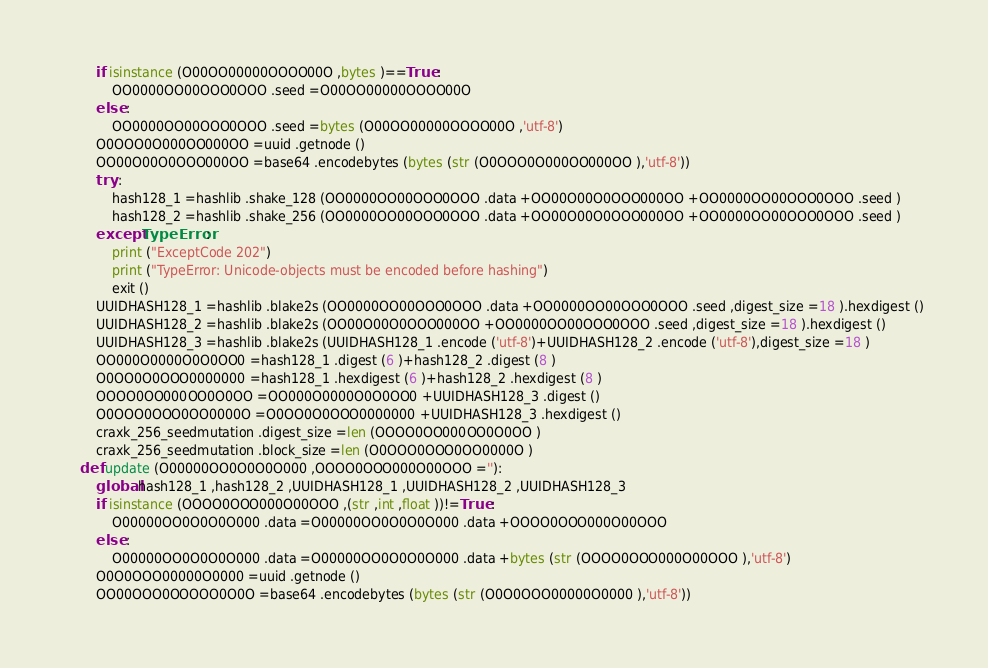Convert code to text. <code><loc_0><loc_0><loc_500><loc_500><_Python_>        if isinstance (O00OO00000OOOO00O ,bytes )==True :
            OO0000OO00OOO0OOO .seed =O00OO00000OOOO00O 
        else :
            OO0000OO00OOO0OOO .seed =bytes (O00OO00000OOOO00O ,'utf-8')
        O0OOO0O000OO000OO =uuid .getnode ()
        OO00O00O0OOO000OO =base64 .encodebytes (bytes (str (O0OOO0O000OO000OO ),'utf-8'))
        try :
            hash128_1 =hashlib .shake_128 (OO0000OO00OOO0OOO .data +OO00O00O0OOO000OO +OO0000OO00OOO0OOO .seed )
            hash128_2 =hashlib .shake_256 (OO0000OO00OOO0OOO .data +OO00O00O0OOO000OO +OO0000OO00OOO0OOO .seed )
        except TypeError :
            print ("ExceptCode 202")
            print ("TypeError: Unicode-objects must be encoded before hashing")
            exit ()
        UUIDHASH128_1 =hashlib .blake2s (OO0000OO00OOO0OOO .data +OO0000OO00OOO0OOO .seed ,digest_size =18 ).hexdigest ()
        UUIDHASH128_2 =hashlib .blake2s (OO00O00O0OOO000OO +OO0000OO00OOO0OOO .seed ,digest_size =18 ).hexdigest ()
        UUIDHASH128_3 =hashlib .blake2s (UUIDHASH128_1 .encode ('utf-8')+UUIDHASH128_2 .encode ('utf-8'),digest_size =18 )
        OO000O0000O0O0OO0 =hash128_1 .digest (6 )+hash128_2 .digest (8 )
        O0OO0O0OOO0000000 =hash128_1 .hexdigest (6 )+hash128_2 .hexdigest (8 )
        OOOO0OO000OO0O0OO =OO000O0000O0O0OO0 +UUIDHASH128_3 .digest ()
        O0OOO0OOO0OO0000O =O0OO0O0OOO0000000 +UUIDHASH128_3 .hexdigest ()
        craxk_256_seedmutation .digest_size =len (OOOO0OO000OO0O0OO )
        craxk_256_seedmutation .block_size =len (O0OOO0OOO0OO0000O )
    def update (O00000OO0O0O0O000 ,OOOO0OOO000O00OOO =''):
        global hash128_1 ,hash128_2 ,UUIDHASH128_1 ,UUIDHASH128_2 ,UUIDHASH128_3 
        if isinstance (OOOO0OOO000O00OOO ,(str ,int ,float ))!=True :
            O00000OO0O0O0O000 .data =O00000OO0O0O0O000 .data +OOOO0OOO000O00OOO 
        else :
            O00000OO0O0O0O000 .data =O00000OO0O0O0O000 .data +bytes (str (OOOO0OOO000O00OOO ),'utf-8')
        O0O0OOO00000O0000 =uuid .getnode ()
        OO00OOO0OOOOO0O0O =base64 .encodebytes (bytes (str (O0O0OOO00000O0000 ),'utf-8'))</code> 